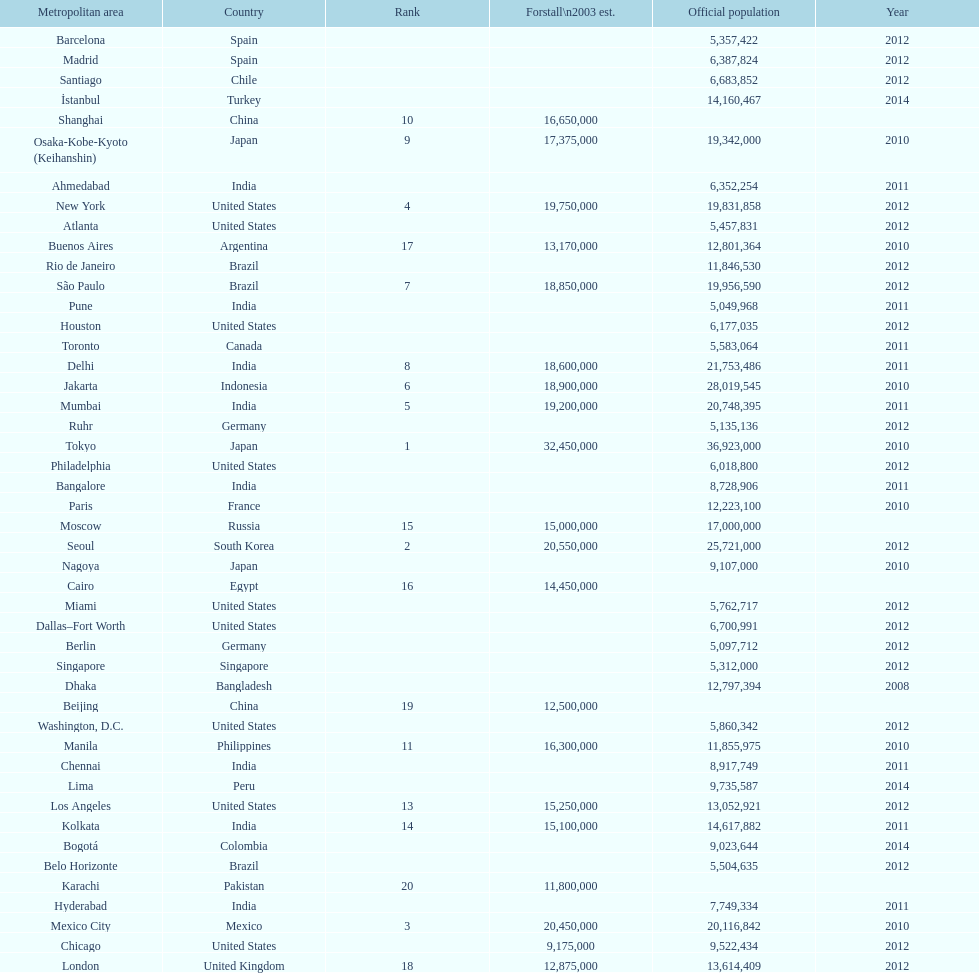What population comes before 5,357,422? 8,728,906. 